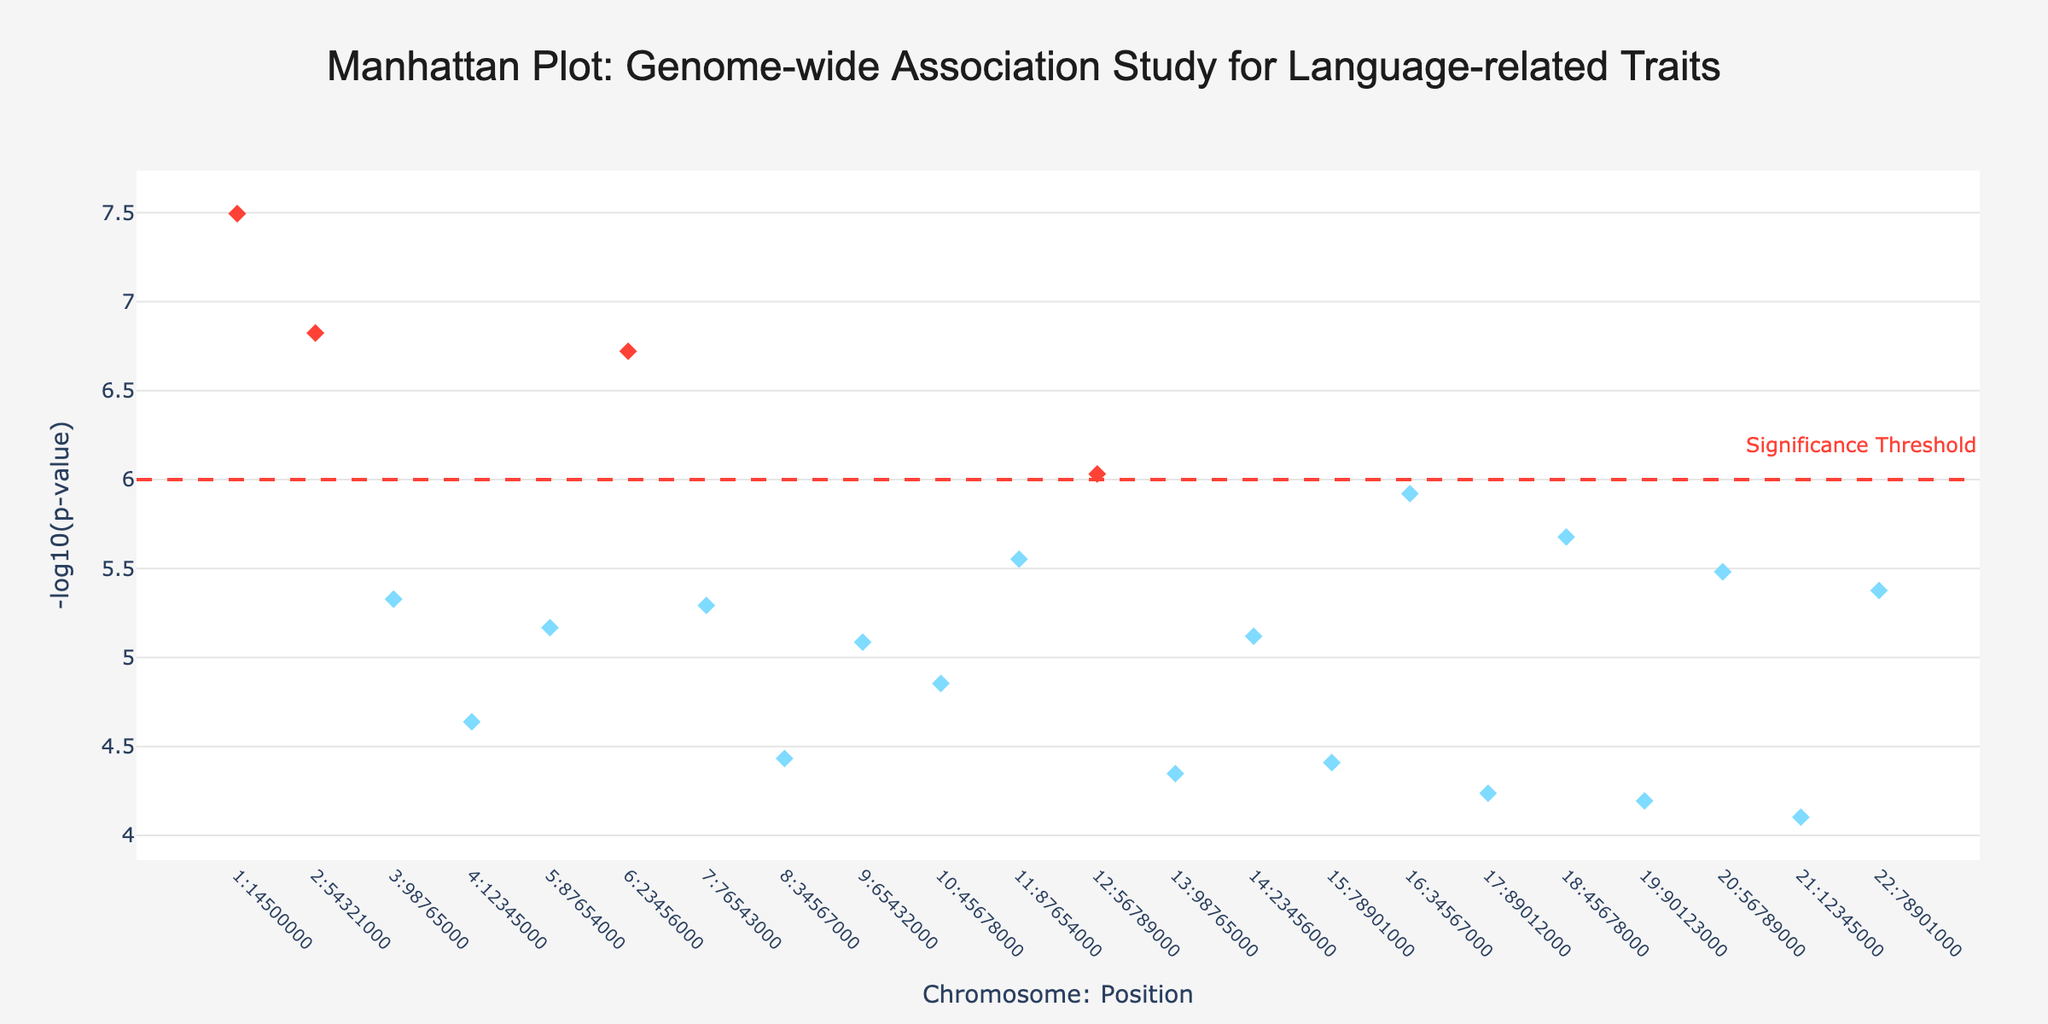What's the title of the plot? The title is typically found at the top of the plot. It often describes what the plot is about.
Answer: Manhattan Plot: Genome-wide Association Study for Language-related Traits Which chromosome has the highest -log10(p-value)? Locate the highest marker on the y-axis, trace to its corresponding x-axis label to find the associated chromosome.
Answer: Chromosome 1 How many data points on the plot exceed the significance threshold? Count the number of markers above the horizontal threshold line at -log10(p-value) of 6.
Answer: 7 Which gene is highlighted as significant on Chromosome 2, and what is its associated trait? Find the data point on Chromosome 2 above the threshold, and check the hovertext or key to locate the gene and associated trait.
Answer: CNTNAP2, Grammar Acquisition What is the -log10(p-value) for the FOXP1 gene? Look for the data point representing FOXP1 and note its y-axis position.
Answer: Approximately 6.03 Compare the -log10(p-value) of FOXP2 and ROBO1. Which one is greater and by how much? Determine the y-axis values for both FOXP2 and ROBO1, then calculate the difference and indicate which is higher. FOXP2 (-log10(3.2e-8)=7.49) and ROBO1 (-log10(1.9e-7)=6.72). FOXP2 is higher by approximately 0.77.
Answer: FOXP2 by 0.77 Which gene on the plot is associated with "Phonological Processing" and what is its -log10(p-value)? Identify the data point using the hovertext for the specified trait, then note the y-axis value.
Answer: DCDC2, approximately 4.64 What color represents data points that do not exceed the significance threshold? Identify the color of markers below the threshold line at -log10(p-value) of 6.
Answer: Light blue (or blue) What chromosome position is ASPM located at and what is its significance level? Locate the data point representing ASPM, then check its hovertext or key for the position and p-value.
Answer: Chromosome 22:78901000, p-value=4.2e-6 What is the total number of chromosomes represented in the plot? Count the unique chromosome labels on the x-axis.
Answer: 22 